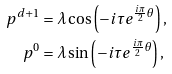<formula> <loc_0><loc_0><loc_500><loc_500>p ^ { d + 1 } & = \lambda \cos \left ( - i \tau e ^ { \frac { i \pi } { 2 } \theta } \right ) , \\ p ^ { 0 } & = \lambda \sin \left ( - i \tau e ^ { \frac { i \pi } { 2 } \theta } \right ) ,</formula> 